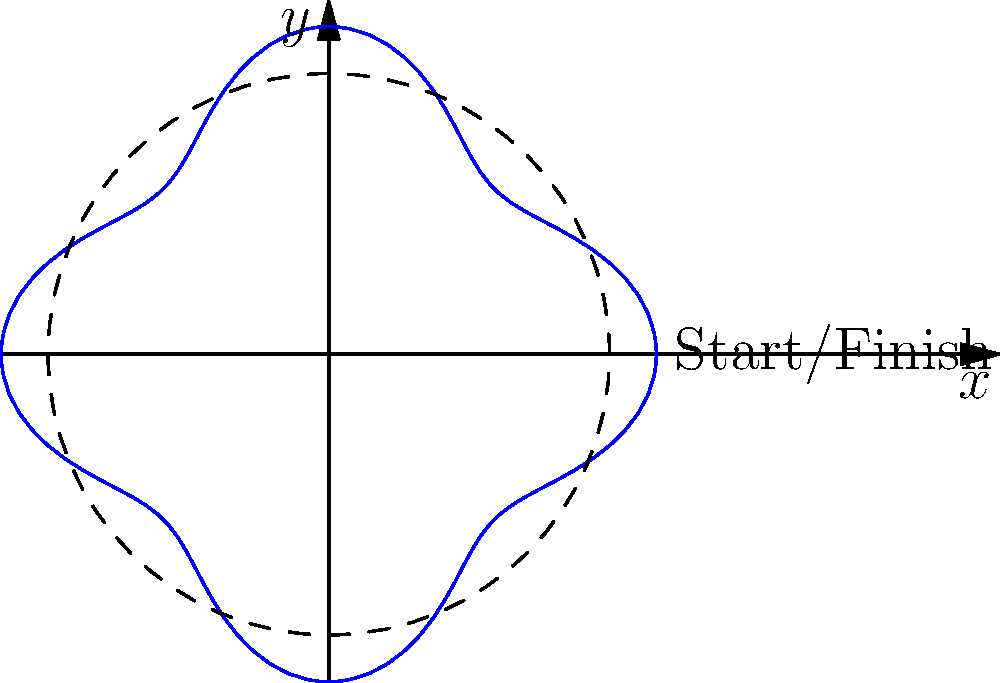In a local velodrome in Burgas, a cyclist's path is modeled by the polar equation $r = 30 + 5\cos(4\theta)$, where $r$ is in meters. If the cyclist completes one lap, what is the total angle traversed in radians? Let's approach this step-by-step:

1) In polar coordinates, a complete revolution around the origin corresponds to an angle of $2\pi$ radians.

2) However, we need to consider the periodicity of the given function. The cosine function in the equation has a factor of 4 inside: $\cos(4\theta)$.

3) This means that the function will complete a full cycle when $4\theta = 2\pi$, or when $\theta = \frac{\pi}{2}$.

4) But this is only a quarter of the velodrome track. To complete a full lap, the cyclist needs to go around four times this amount.

5) Therefore, the total angle traversed for one complete lap is:

   $4 \cdot \frac{\pi}{2} = 2\pi$ radians

This makes sense geometrically as well, as one complete lap around the velodrome should indeed correspond to one full revolution of $2\pi$ radians.
Answer: $2\pi$ radians 